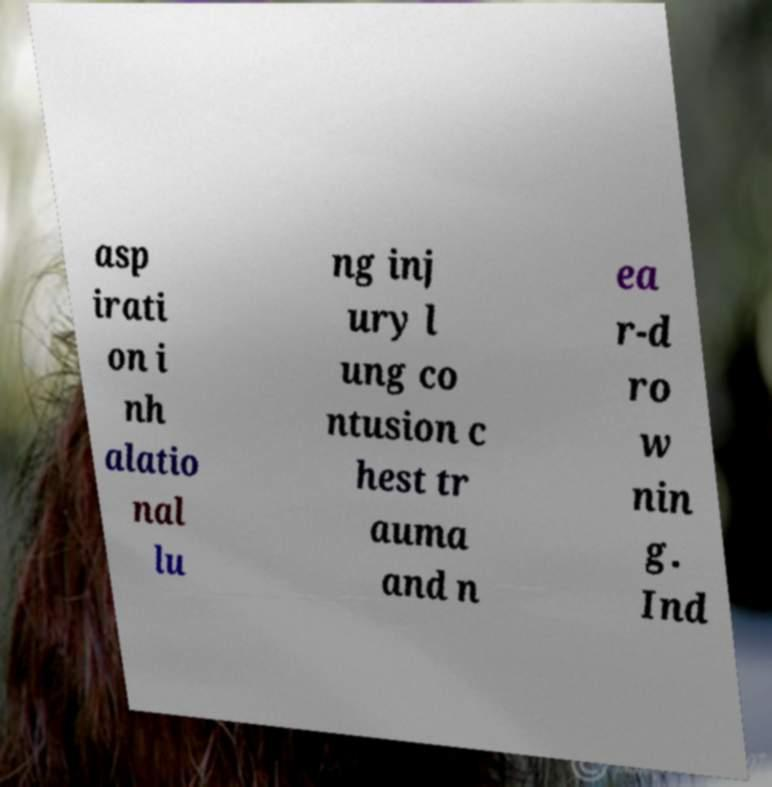There's text embedded in this image that I need extracted. Can you transcribe it verbatim? asp irati on i nh alatio nal lu ng inj ury l ung co ntusion c hest tr auma and n ea r-d ro w nin g. Ind 